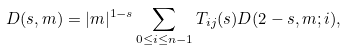Convert formula to latex. <formula><loc_0><loc_0><loc_500><loc_500>D ( s , m ) = | m | ^ { 1 - s } \sum _ { 0 \leq i \leq n - 1 } T _ { i j } ( s ) D ( 2 - s , m ; i ) ,</formula> 